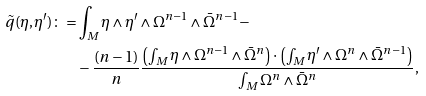Convert formula to latex. <formula><loc_0><loc_0><loc_500><loc_500>\tilde { q } ( \eta , \eta ^ { \prime } ) \colon = & \int _ { M } \eta \wedge \eta ^ { \prime } \wedge \Omega ^ { n - 1 } \wedge \bar { \Omega } ^ { n - 1 } - \\ & - \frac { ( n - 1 ) } n \frac { \left ( \int _ { M } \eta \wedge \Omega ^ { n - 1 } \wedge \bar { \Omega } ^ { n } \right ) \cdot \left ( \int _ { M } \eta ^ { \prime } \wedge \Omega ^ { n } \wedge \bar { \Omega } ^ { n - 1 } \right ) } { \int _ { M } \Omega ^ { n } \wedge \bar { \Omega } ^ { n } } ,</formula> 